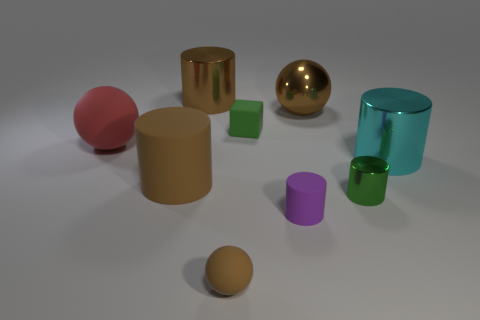There is a matte ball left of the matte cylinder that is to the left of the small green rubber block; what number of brown objects are behind it?
Offer a very short reply. 2. What material is the large brown cylinder that is behind the big brown thing on the right side of the brown thing in front of the green cylinder?
Offer a very short reply. Metal. Is the material of the brown ball in front of the cyan metal cylinder the same as the purple cylinder?
Your response must be concise. Yes. What number of things are the same size as the brown rubber ball?
Make the answer very short. 3. Are there more cylinders that are behind the big brown matte object than rubber objects behind the large red thing?
Your response must be concise. Yes. Is there another green metallic object that has the same shape as the tiny metallic thing?
Your response must be concise. No. What size is the sphere to the left of the brown shiny object that is to the left of the small matte cylinder?
Your response must be concise. Large. There is a tiny object that is in front of the purple rubber object that is to the right of the large rubber object in front of the cyan shiny cylinder; what is its shape?
Your response must be concise. Sphere. There is a brown sphere that is made of the same material as the red ball; what is its size?
Offer a very short reply. Small. Are there more green matte things than big objects?
Give a very brief answer. No. 